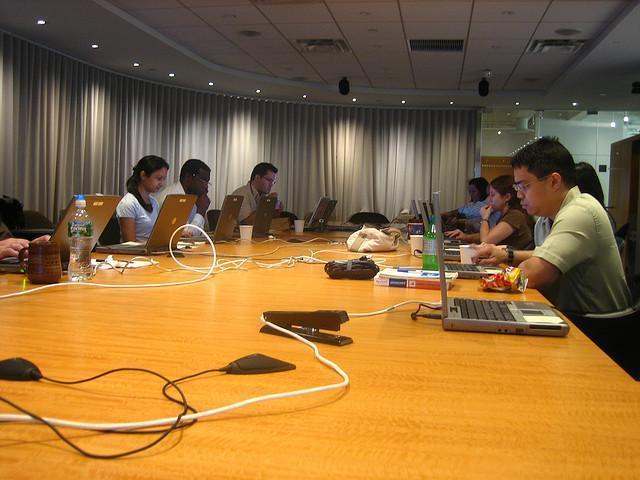How many people are there?
Give a very brief answer. 3. How many laptops are there?
Give a very brief answer. 2. 